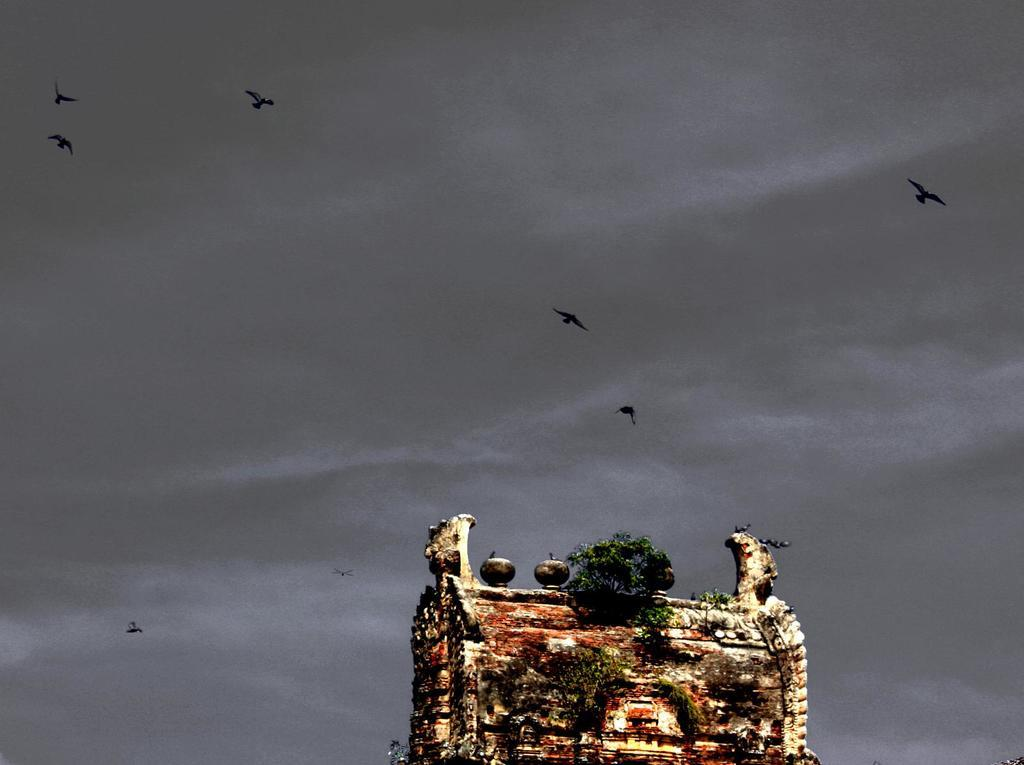What is the main subject of the image? The image shows the top of a building. Are there any plants visible on the building? Yes, there is a tree on the building. What can be seen in the background of the image? The sky is visible in the background. What type of animals can be seen in the image? Birds are flying in the image. What is the income of the person who owns the bed in the image? There is no bed present in the image, so it is not possible to determine the income of the person who owns it. 